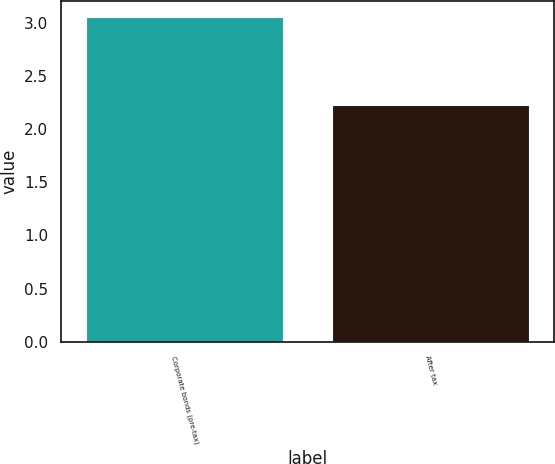Convert chart. <chart><loc_0><loc_0><loc_500><loc_500><bar_chart><fcel>Corporate bonds (pre-tax)<fcel>After tax<nl><fcel>3.05<fcel>2.23<nl></chart> 